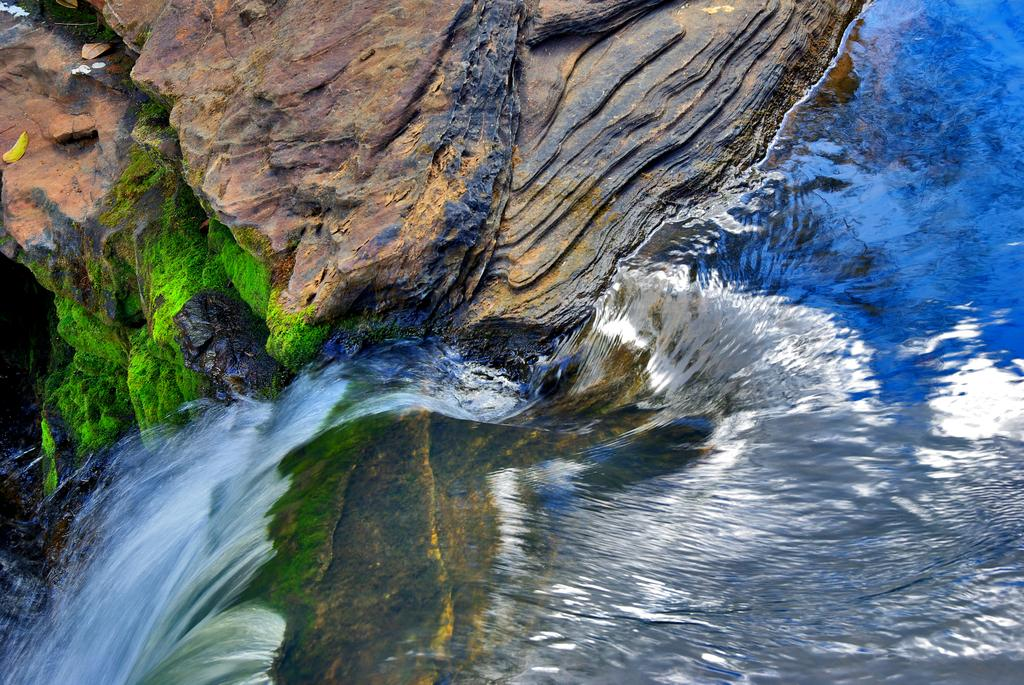What is the primary element in motion in the image? There is water flowing in the image. What type of vegetation can be seen in the background of the image? The background of the image includes grass in green color. What geological feature is visible in the image? There is a rock visible in the image. What type of account does the squirrel have in the image? There is no squirrel present in the image, so it is not possible to determine if it has an account or not. 